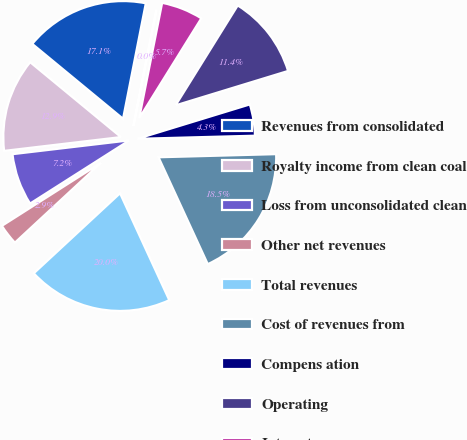Convert chart to OTSL. <chart><loc_0><loc_0><loc_500><loc_500><pie_chart><fcel>Revenues from consolidated<fcel>Royalty income from clean coal<fcel>Loss from unconsolidated clean<fcel>Other net revenues<fcel>Total revenues<fcel>Cost of revenues from<fcel>Compens ation<fcel>Operating<fcel>Interest<fcel>Depreciation<nl><fcel>17.12%<fcel>12.85%<fcel>7.15%<fcel>2.88%<fcel>19.97%<fcel>18.55%<fcel>4.3%<fcel>11.42%<fcel>5.73%<fcel>0.03%<nl></chart> 